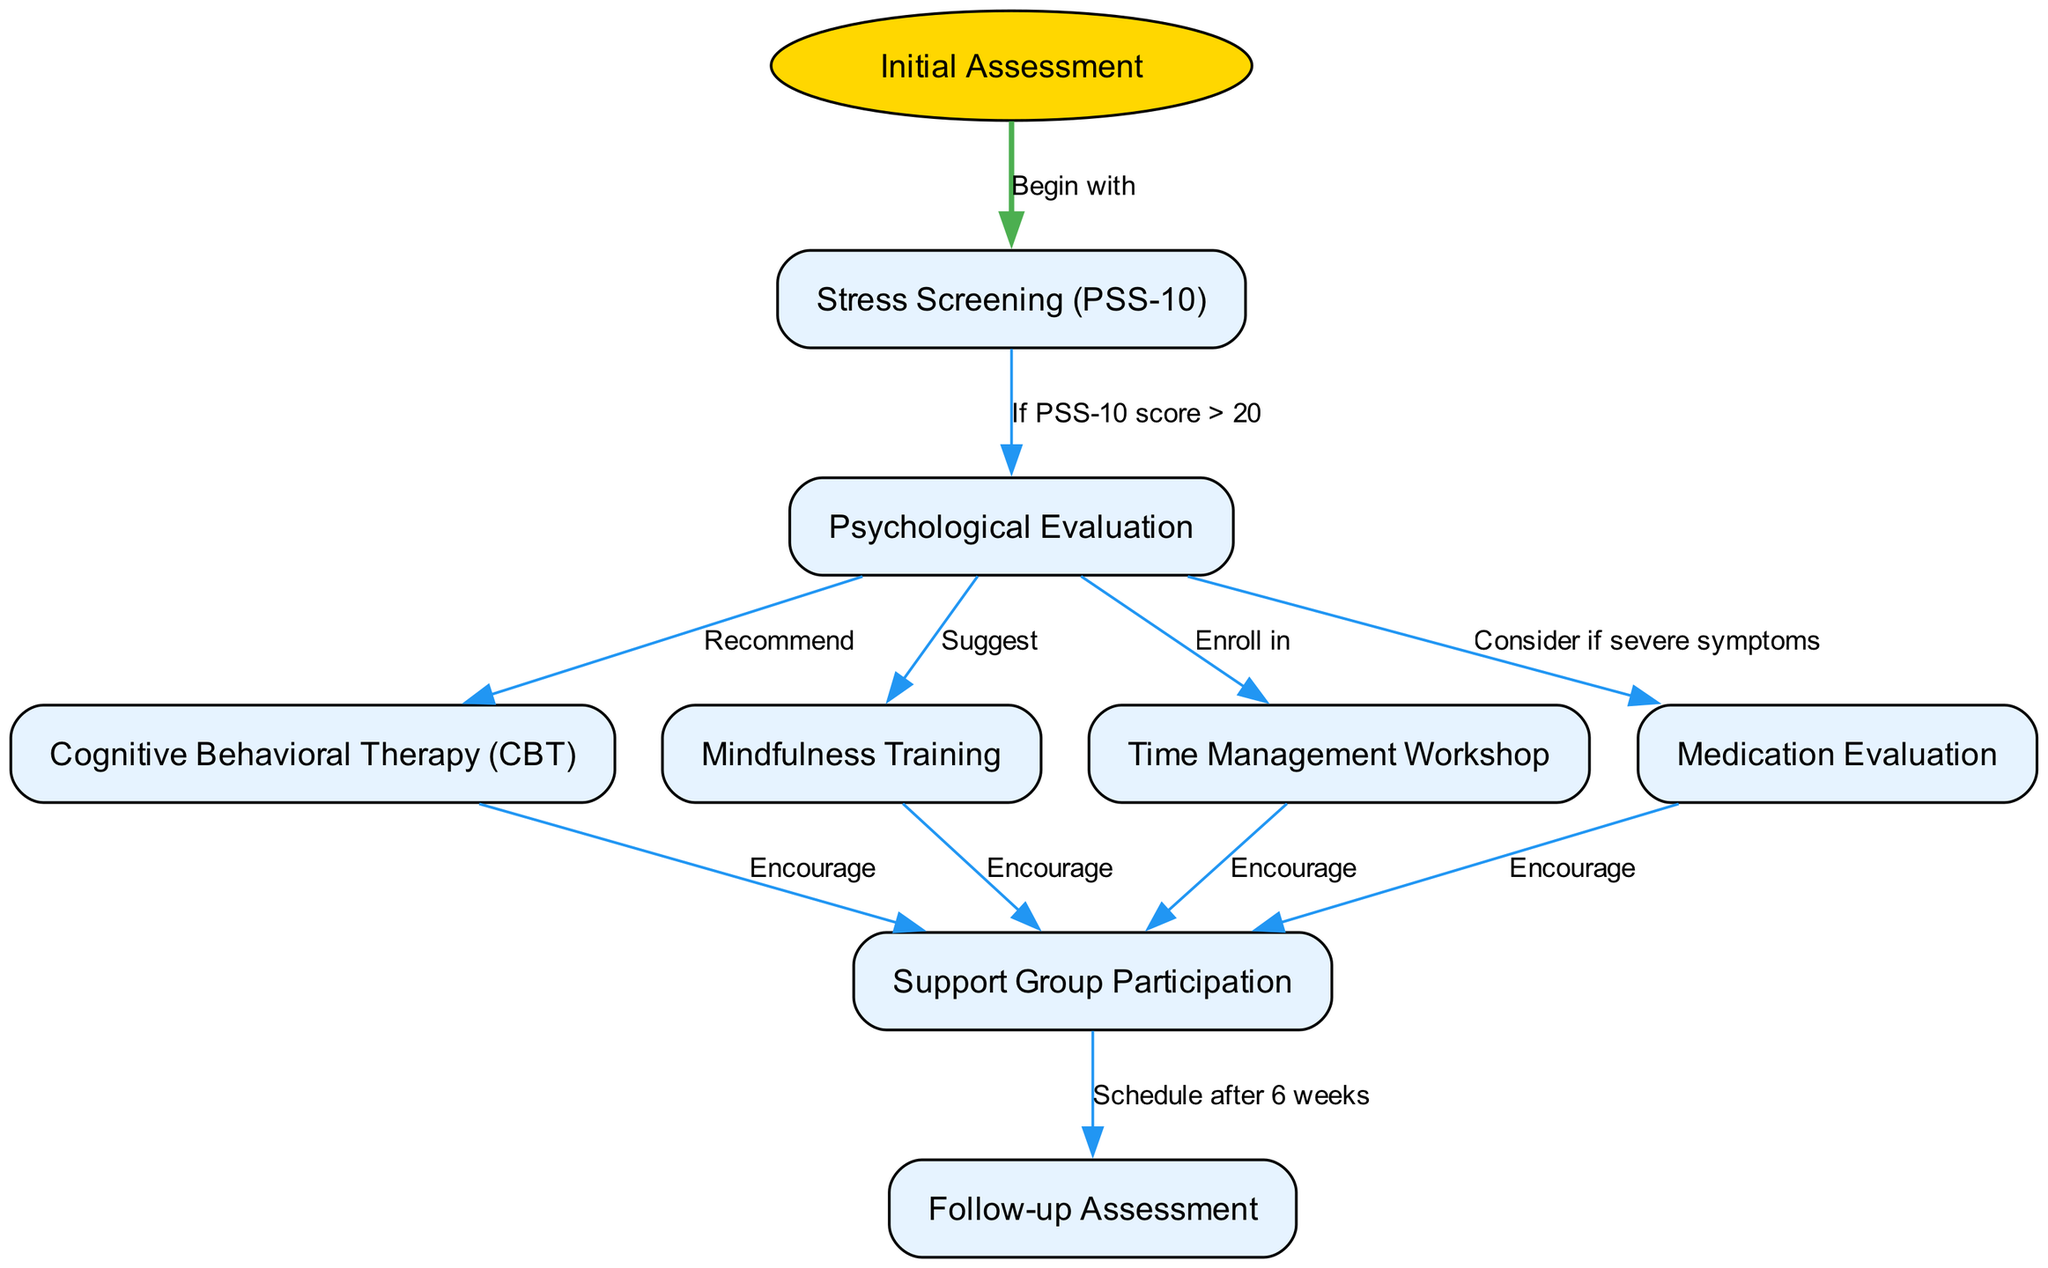What is the first step in the clinical pathway? The clinical pathway begins at the 'Initial Assessment' node, which indicates the starting point of the treatment protocol for stress-related disorders.
Answer: Initial Assessment How many nodes are in the diagram? The diagram contains a total of 8 nodes, including the start point and the subsequent treatment options.
Answer: 8 What is suggested after a psychological evaluation? After a psychological evaluation, it is suggested to 'Suggest Mindfulness Training', indicating a recommended treatment method for managing stress.
Answer: Suggest Mindfulness Training What should be encouraged after Cognitive Behavioral Therapy? After completing Cognitive Behavioral Therapy, clients are encouraged to participate in a support group, which provides additional help and community support.
Answer: Encourage Support Group Participation If the PSS-10 score is greater than 20, what is the next step? If the PSS-10 score is greater than 20, the next step is to perform a 'Psychological Evaluation' to assess the individual's mental health more deeply.
Answer: Psychological Evaluation What is the relationship between Medication Evaluation and Support Group Participation? Medication Evaluation is considered if there are severe symptoms, and it encourages Support Group Participation, meaning that both are connected through the need for support in treatment.
Answer: Encourage Support Group Participation Which node has the final follow-up step? The final follow-up step is located at the 'Follow-up Assessment' node, which occurs after all recommended treatments and support group sessions.
Answer: Follow-up Assessment What step follows after support group participation? The step that follows after support group participation is the 'Follow-up Assessment', which is scheduled six weeks later to evaluate progress.
Answer: Follow-up Assessment 